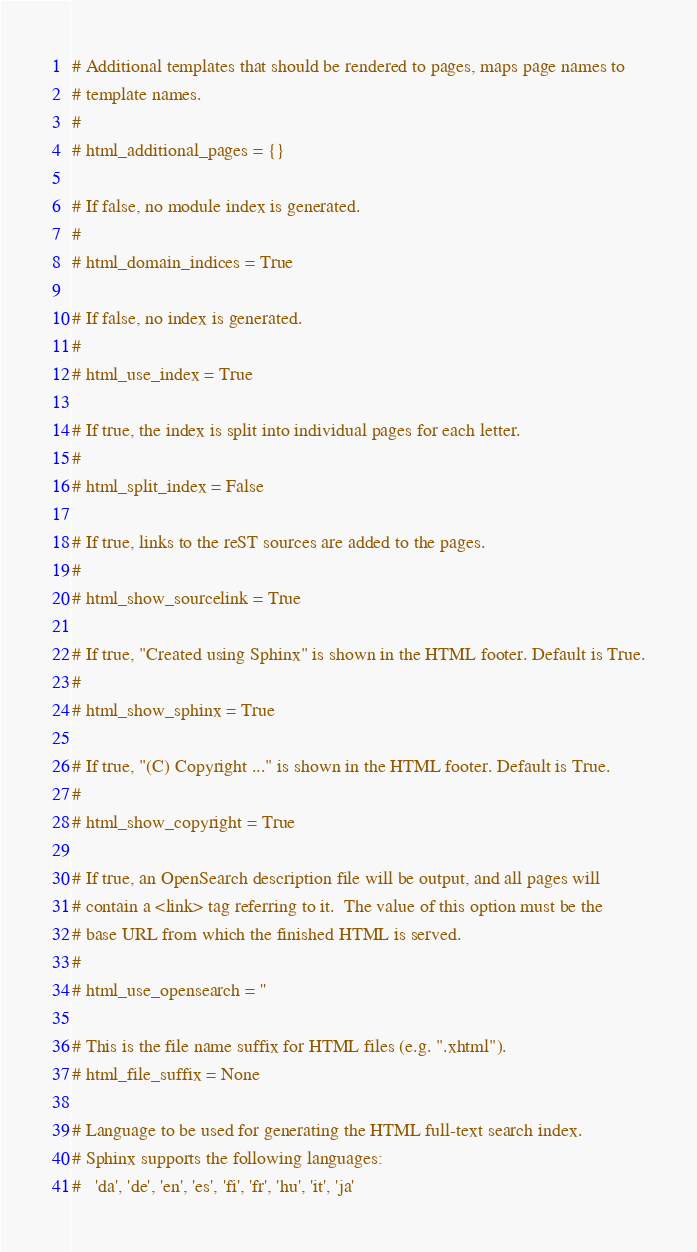Convert code to text. <code><loc_0><loc_0><loc_500><loc_500><_Python_># Additional templates that should be rendered to pages, maps page names to
# template names.
#
# html_additional_pages = {}

# If false, no module index is generated.
#
# html_domain_indices = True

# If false, no index is generated.
#
# html_use_index = True

# If true, the index is split into individual pages for each letter.
#
# html_split_index = False

# If true, links to the reST sources are added to the pages.
#
# html_show_sourcelink = True

# If true, "Created using Sphinx" is shown in the HTML footer. Default is True.
#
# html_show_sphinx = True

# If true, "(C) Copyright ..." is shown in the HTML footer. Default is True.
#
# html_show_copyright = True

# If true, an OpenSearch description file will be output, and all pages will
# contain a <link> tag referring to it.  The value of this option must be the
# base URL from which the finished HTML is served.
#
# html_use_opensearch = ''

# This is the file name suffix for HTML files (e.g. ".xhtml").
# html_file_suffix = None

# Language to be used for generating the HTML full-text search index.
# Sphinx supports the following languages:
#   'da', 'de', 'en', 'es', 'fi', 'fr', 'hu', 'it', 'ja'</code> 